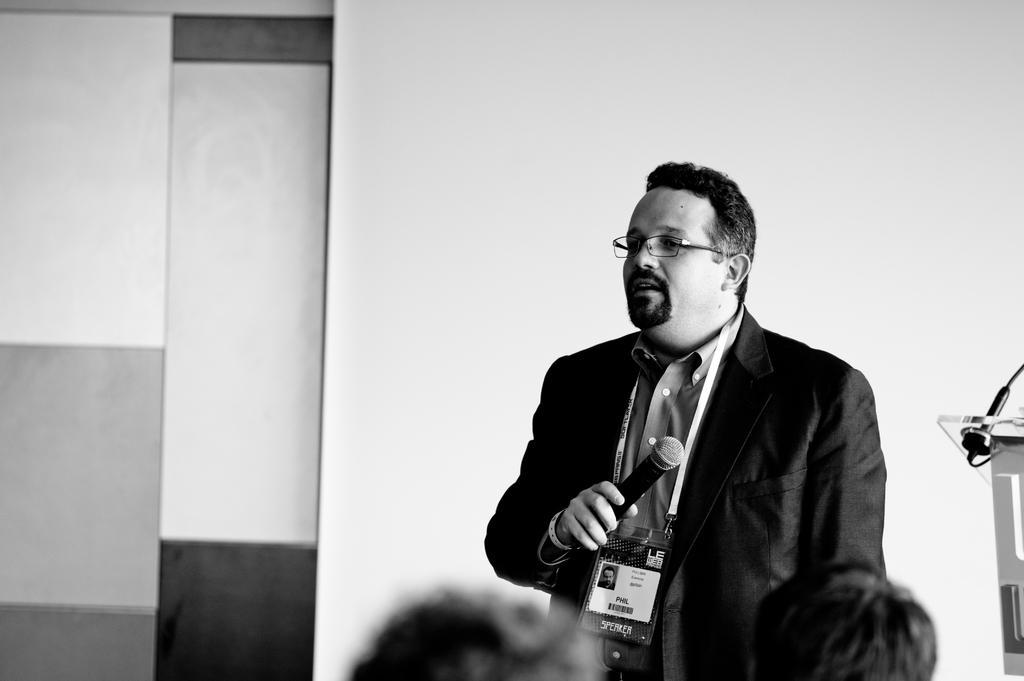In one or two sentences, can you explain what this image depicts? In this image i can see a person standing wearing a blazer and identity card is holding a microphone. In the background i can see the wall and a podium. 